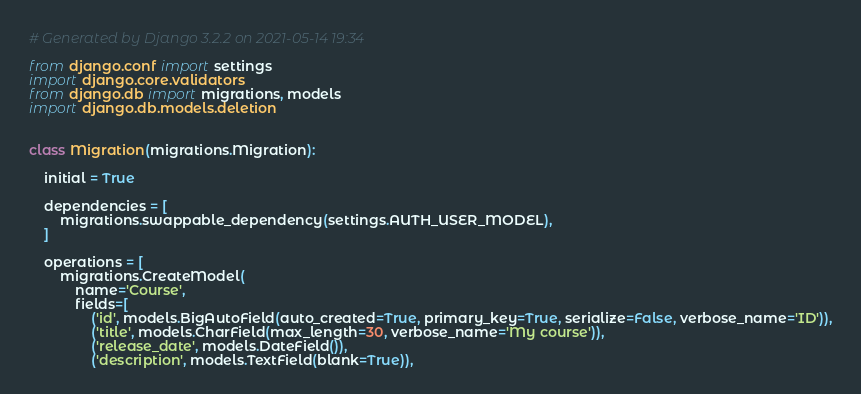<code> <loc_0><loc_0><loc_500><loc_500><_Python_># Generated by Django 3.2.2 on 2021-05-14 19:34

from django.conf import settings
import django.core.validators
from django.db import migrations, models
import django.db.models.deletion


class Migration(migrations.Migration):

    initial = True

    dependencies = [
        migrations.swappable_dependency(settings.AUTH_USER_MODEL),
    ]

    operations = [
        migrations.CreateModel(
            name='Course',
            fields=[
                ('id', models.BigAutoField(auto_created=True, primary_key=True, serialize=False, verbose_name='ID')),
                ('title', models.CharField(max_length=30, verbose_name='My course')),
                ('release_date', models.DateField()),
                ('description', models.TextField(blank=True)),</code> 